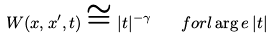<formula> <loc_0><loc_0><loc_500><loc_500>W ( x , x ^ { \prime } , t ) \cong | t | ^ { - \gamma } \quad f o r l \arg e \, | t |</formula> 